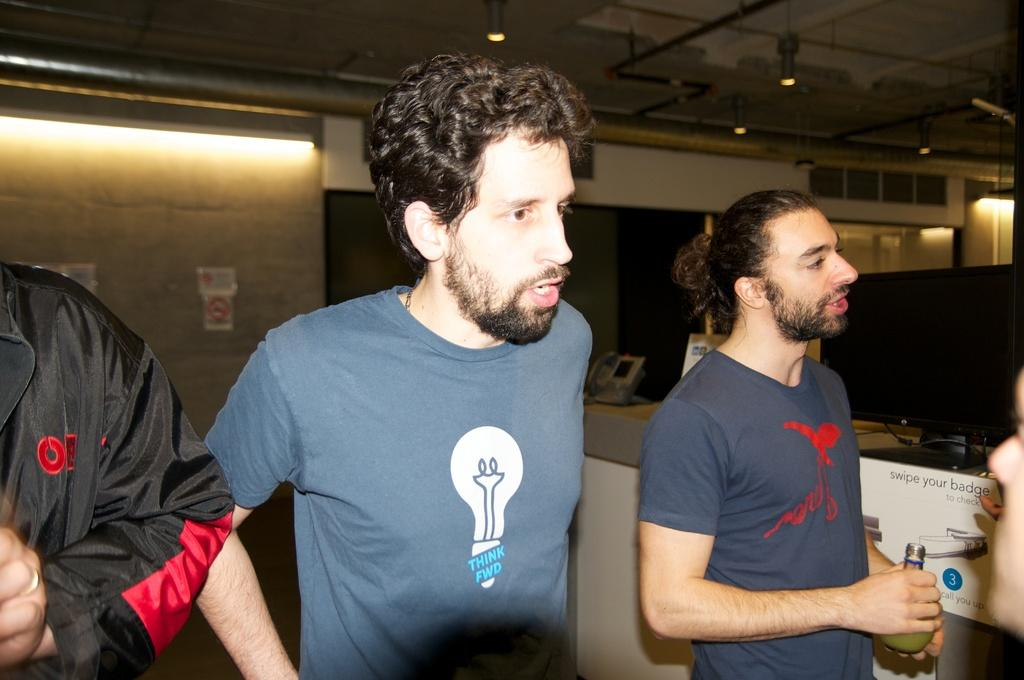<image>
Create a compact narrative representing the image presented. A group of men are standing by a computer desk and one of their shirts says Think Fwd. 